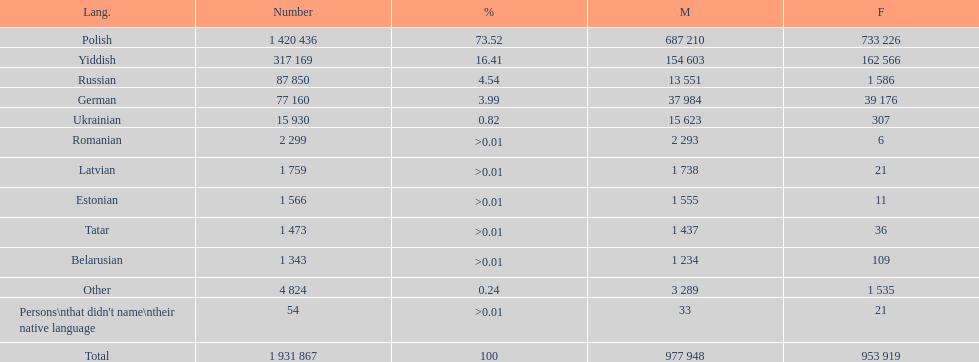The least amount of females Romanian. 